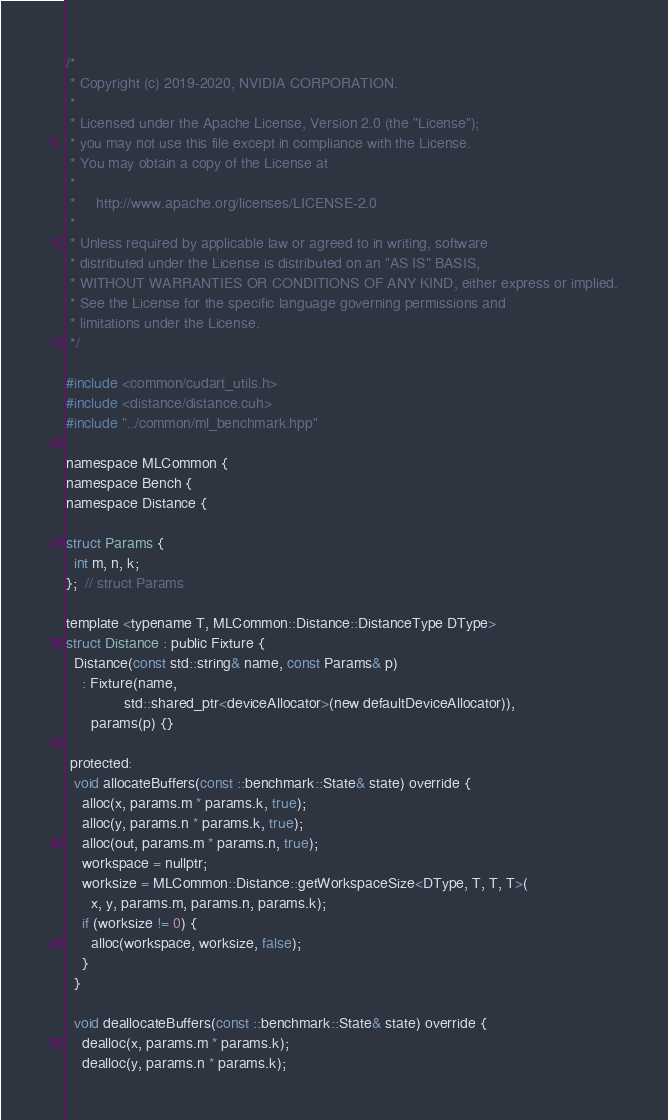Convert code to text. <code><loc_0><loc_0><loc_500><loc_500><_Cuda_>/*
 * Copyright (c) 2019-2020, NVIDIA CORPORATION.
 *
 * Licensed under the Apache License, Version 2.0 (the "License");
 * you may not use this file except in compliance with the License.
 * You may obtain a copy of the License at
 *
 *     http://www.apache.org/licenses/LICENSE-2.0
 *
 * Unless required by applicable law or agreed to in writing, software
 * distributed under the License is distributed on an "AS IS" BASIS,
 * WITHOUT WARRANTIES OR CONDITIONS OF ANY KIND, either express or implied.
 * See the License for the specific language governing permissions and
 * limitations under the License.
 */

#include <common/cudart_utils.h>
#include <distance/distance.cuh>
#include "../common/ml_benchmark.hpp"

namespace MLCommon {
namespace Bench {
namespace Distance {

struct Params {
  int m, n, k;
};  // struct Params

template <typename T, MLCommon::Distance::DistanceType DType>
struct Distance : public Fixture {
  Distance(const std::string& name, const Params& p)
    : Fixture(name,
              std::shared_ptr<deviceAllocator>(new defaultDeviceAllocator)),
      params(p) {}

 protected:
  void allocateBuffers(const ::benchmark::State& state) override {
    alloc(x, params.m * params.k, true);
    alloc(y, params.n * params.k, true);
    alloc(out, params.m * params.n, true);
    workspace = nullptr;
    worksize = MLCommon::Distance::getWorkspaceSize<DType, T, T, T>(
      x, y, params.m, params.n, params.k);
    if (worksize != 0) {
      alloc(workspace, worksize, false);
    }
  }

  void deallocateBuffers(const ::benchmark::State& state) override {
    dealloc(x, params.m * params.k);
    dealloc(y, params.n * params.k);</code> 